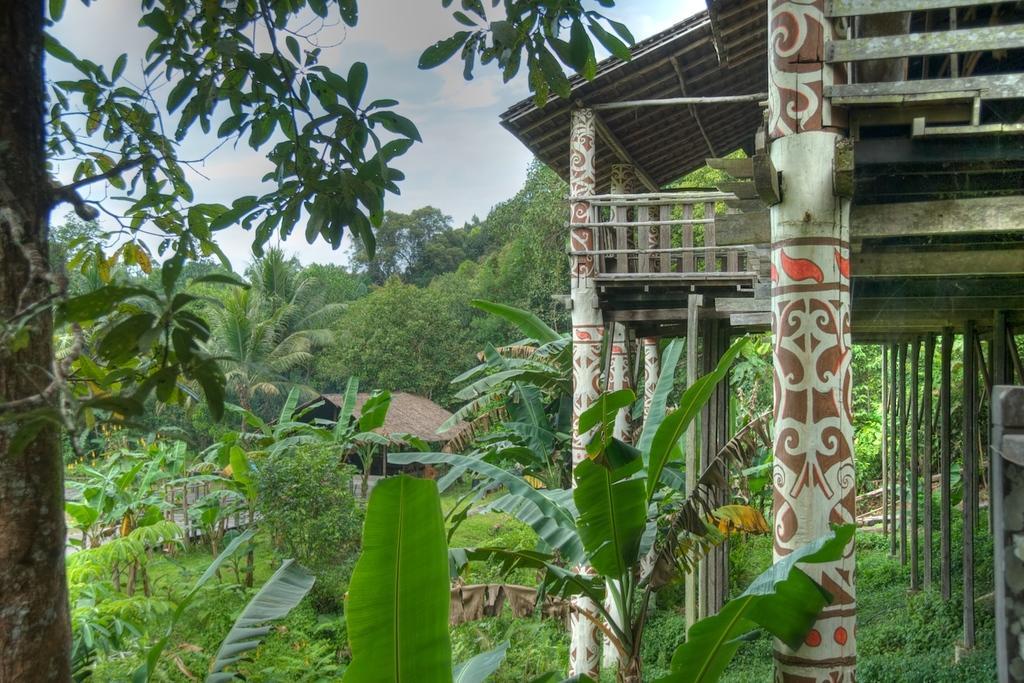Describe this image in one or two sentences. In this image, I can see trees, plants and a house. On the right side of the image, I can see a shed with pillars. In the background, there is the sky. 